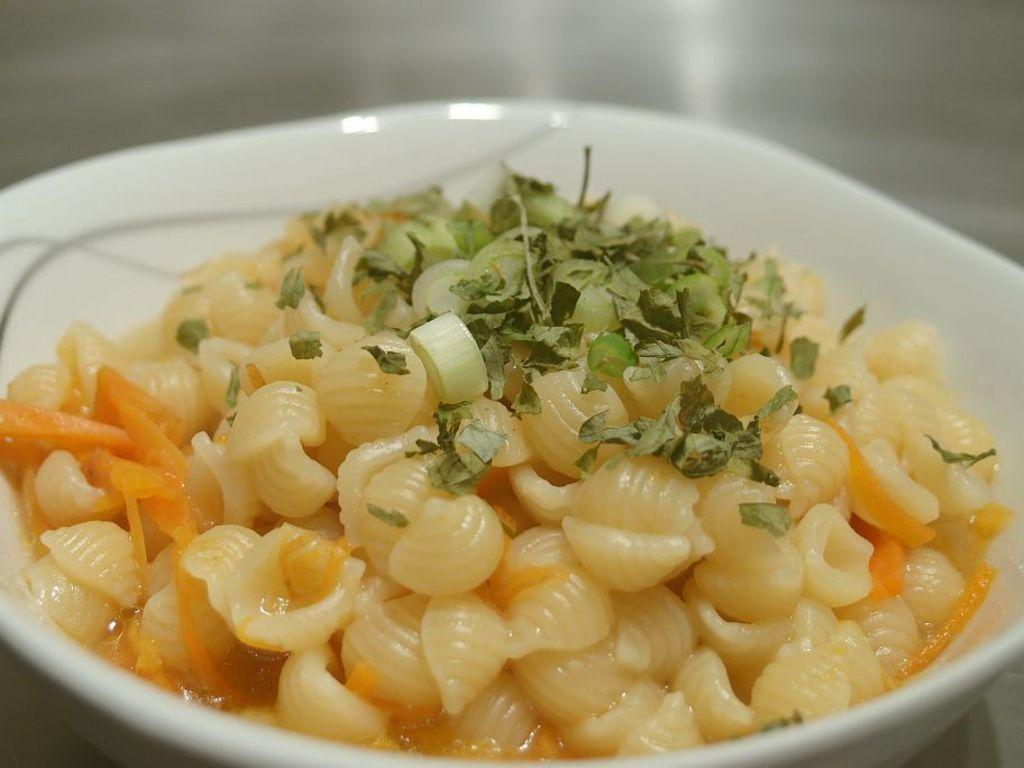What is in the bowl that is visible in the image? There is a bowl with food items in the image. What type of herb can be seen on the food items? There are coriander leaves on the food items. What color of paint is used to decorate the food items in the image? There is no paint visible on the food items in the image. What mathematical operation is being performed on the food items in the image? There is no indication of any mathematical operation being performed on the food items in the image. 